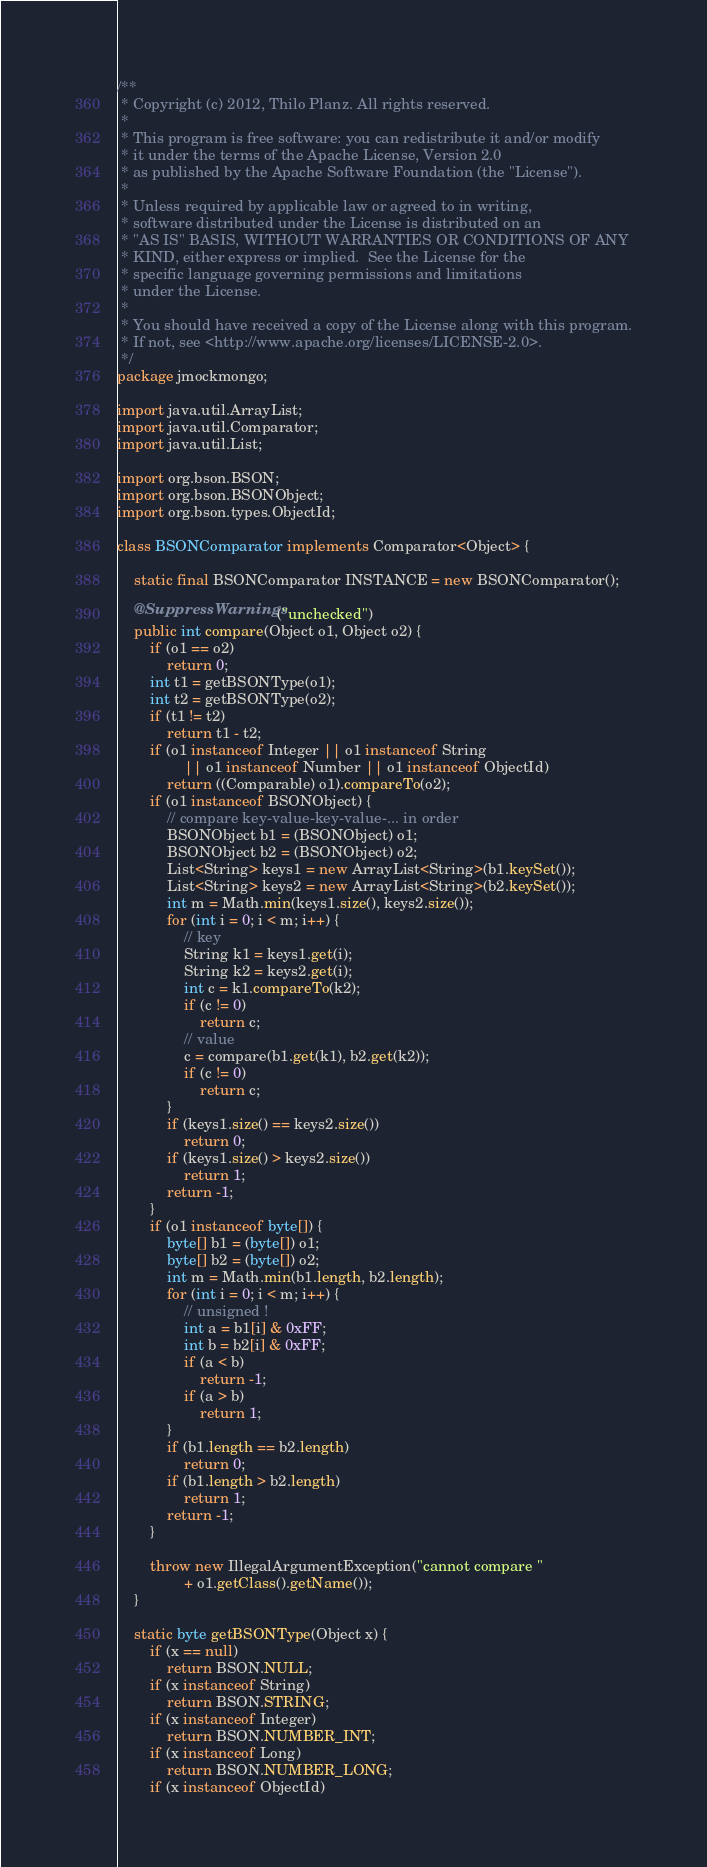Convert code to text. <code><loc_0><loc_0><loc_500><loc_500><_Java_>/**
 * Copyright (c) 2012, Thilo Planz. All rights reserved.
 *
 * This program is free software: you can redistribute it and/or modify
 * it under the terms of the Apache License, Version 2.0
 * as published by the Apache Software Foundation (the "License").
 *
 * Unless required by applicable law or agreed to in writing,
 * software distributed under the License is distributed on an
 * "AS IS" BASIS, WITHOUT WARRANTIES OR CONDITIONS OF ANY
 * KIND, either express or implied.  See the License for the
 * specific language governing permissions and limitations
 * under the License.
 *
 * You should have received a copy of the License along with this program.
 * If not, see <http://www.apache.org/licenses/LICENSE-2.0>.
 */
package jmockmongo;

import java.util.ArrayList;
import java.util.Comparator;
import java.util.List;

import org.bson.BSON;
import org.bson.BSONObject;
import org.bson.types.ObjectId;

class BSONComparator implements Comparator<Object> {

	static final BSONComparator INSTANCE = new BSONComparator();

	@SuppressWarnings("unchecked")
	public int compare(Object o1, Object o2) {
		if (o1 == o2)
			return 0;
		int t1 = getBSONType(o1);
		int t2 = getBSONType(o2);
		if (t1 != t2)
			return t1 - t2;
		if (o1 instanceof Integer || o1 instanceof String
				|| o1 instanceof Number || o1 instanceof ObjectId)
			return ((Comparable) o1).compareTo(o2);
		if (o1 instanceof BSONObject) {
			// compare key-value-key-value-... in order
			BSONObject b1 = (BSONObject) o1;
			BSONObject b2 = (BSONObject) o2;
			List<String> keys1 = new ArrayList<String>(b1.keySet());
			List<String> keys2 = new ArrayList<String>(b2.keySet());
			int m = Math.min(keys1.size(), keys2.size());
			for (int i = 0; i < m; i++) {
				// key
				String k1 = keys1.get(i);
				String k2 = keys2.get(i);
				int c = k1.compareTo(k2);
				if (c != 0)
					return c;
				// value
				c = compare(b1.get(k1), b2.get(k2));
				if (c != 0)
					return c;
			}
			if (keys1.size() == keys2.size())
				return 0;
			if (keys1.size() > keys2.size())
				return 1;
			return -1;
		}
		if (o1 instanceof byte[]) {
			byte[] b1 = (byte[]) o1;
			byte[] b2 = (byte[]) o2;
			int m = Math.min(b1.length, b2.length);
			for (int i = 0; i < m; i++) {
				// unsigned !
				int a = b1[i] & 0xFF;
				int b = b2[i] & 0xFF;
				if (a < b)
					return -1;
				if (a > b)
					return 1;
			}
			if (b1.length == b2.length)
				return 0;
			if (b1.length > b2.length)
				return 1;
			return -1;
		}

		throw new IllegalArgumentException("cannot compare "
				+ o1.getClass().getName());
	}

	static byte getBSONType(Object x) {
		if (x == null)
			return BSON.NULL;
		if (x instanceof String)
			return BSON.STRING;
		if (x instanceof Integer)
			return BSON.NUMBER_INT;
		if (x instanceof Long)
			return BSON.NUMBER_LONG;
		if (x instanceof ObjectId)</code> 